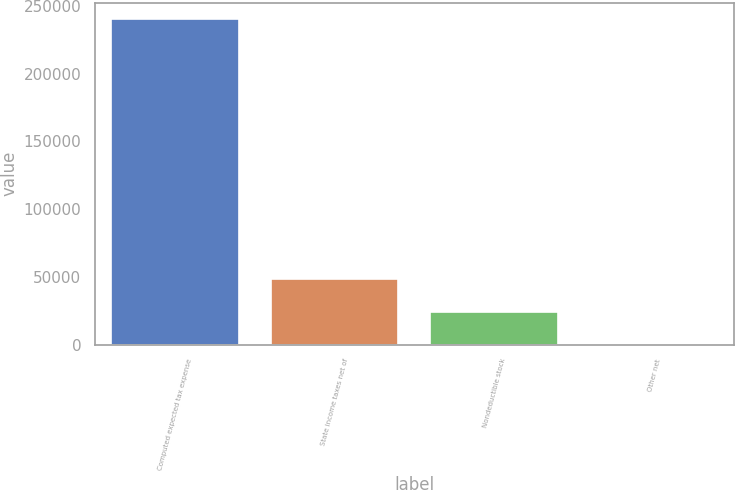Convert chart to OTSL. <chart><loc_0><loc_0><loc_500><loc_500><bar_chart><fcel>Computed expected tax expense<fcel>State income taxes net of<fcel>Nondeductible stock<fcel>Other net<nl><fcel>240400<fcel>48508<fcel>24521.5<fcel>535<nl></chart> 